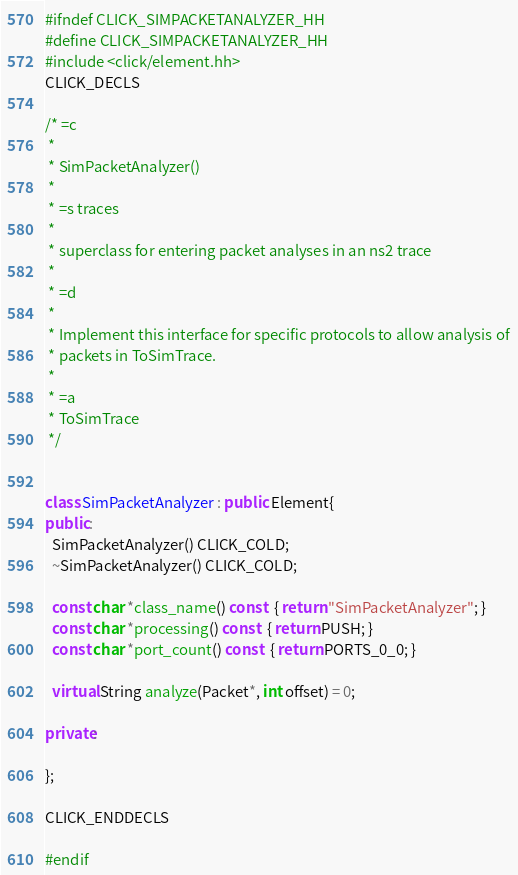<code> <loc_0><loc_0><loc_500><loc_500><_C++_>#ifndef CLICK_SIMPACKETANALYZER_HH
#define CLICK_SIMPACKETANALYZER_HH
#include <click/element.hh>
CLICK_DECLS

/* =c
 *
 * SimPacketAnalyzer()
 *
 * =s traces
 *
 * superclass for entering packet analyses in an ns2 trace
 *
 * =d
 *
 * Implement this interface for specific protocols to allow analysis of
 * packets in ToSimTrace.
 *
 * =a
 * ToSimTrace
 */


class SimPacketAnalyzer : public Element{
public:
  SimPacketAnalyzer() CLICK_COLD;
  ~SimPacketAnalyzer() CLICK_COLD;

  const char *class_name() const  { return "SimPacketAnalyzer"; }
  const char *processing() const  { return PUSH; }
  const char *port_count() const  { return PORTS_0_0; }

  virtual String analyze(Packet*, int offset) = 0;

private:

};

CLICK_ENDDECLS

#endif

</code> 